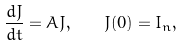<formula> <loc_0><loc_0><loc_500><loc_500>\frac { d J } { d t } = A J , \quad J ( 0 ) = I _ { n } ,</formula> 